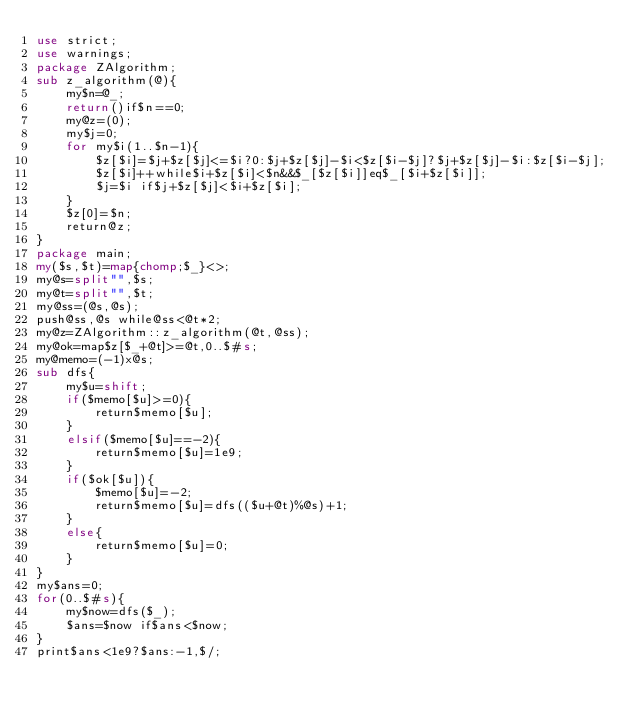Convert code to text. <code><loc_0><loc_0><loc_500><loc_500><_Perl_>use strict;
use warnings;
package ZAlgorithm;
sub z_algorithm(@){
	my$n=@_;
	return()if$n==0;
	my@z=(0);
	my$j=0;
	for my$i(1..$n-1){
		$z[$i]=$j+$z[$j]<=$i?0:$j+$z[$j]-$i<$z[$i-$j]?$j+$z[$j]-$i:$z[$i-$j];
		$z[$i]++while$i+$z[$i]<$n&&$_[$z[$i]]eq$_[$i+$z[$i]];
		$j=$i if$j+$z[$j]<$i+$z[$i];
	}
	$z[0]=$n;
	return@z;
}
package main;
my($s,$t)=map{chomp;$_}<>;
my@s=split"",$s;
my@t=split"",$t;
my@ss=(@s,@s);
push@ss,@s while@ss<@t*2;
my@z=ZAlgorithm::z_algorithm(@t,@ss);
my@ok=map$z[$_+@t]>=@t,0..$#s;
my@memo=(-1)x@s;
sub dfs{
	my$u=shift;
	if($memo[$u]>=0){
		return$memo[$u];
	}
	elsif($memo[$u]==-2){
		return$memo[$u]=1e9;
	}
	if($ok[$u]){
		$memo[$u]=-2;
		return$memo[$u]=dfs(($u+@t)%@s)+1;
	}
	else{
		return$memo[$u]=0;
	}
}
my$ans=0;
for(0..$#s){
	my$now=dfs($_);
	$ans=$now if$ans<$now;
}
print$ans<1e9?$ans:-1,$/;
</code> 